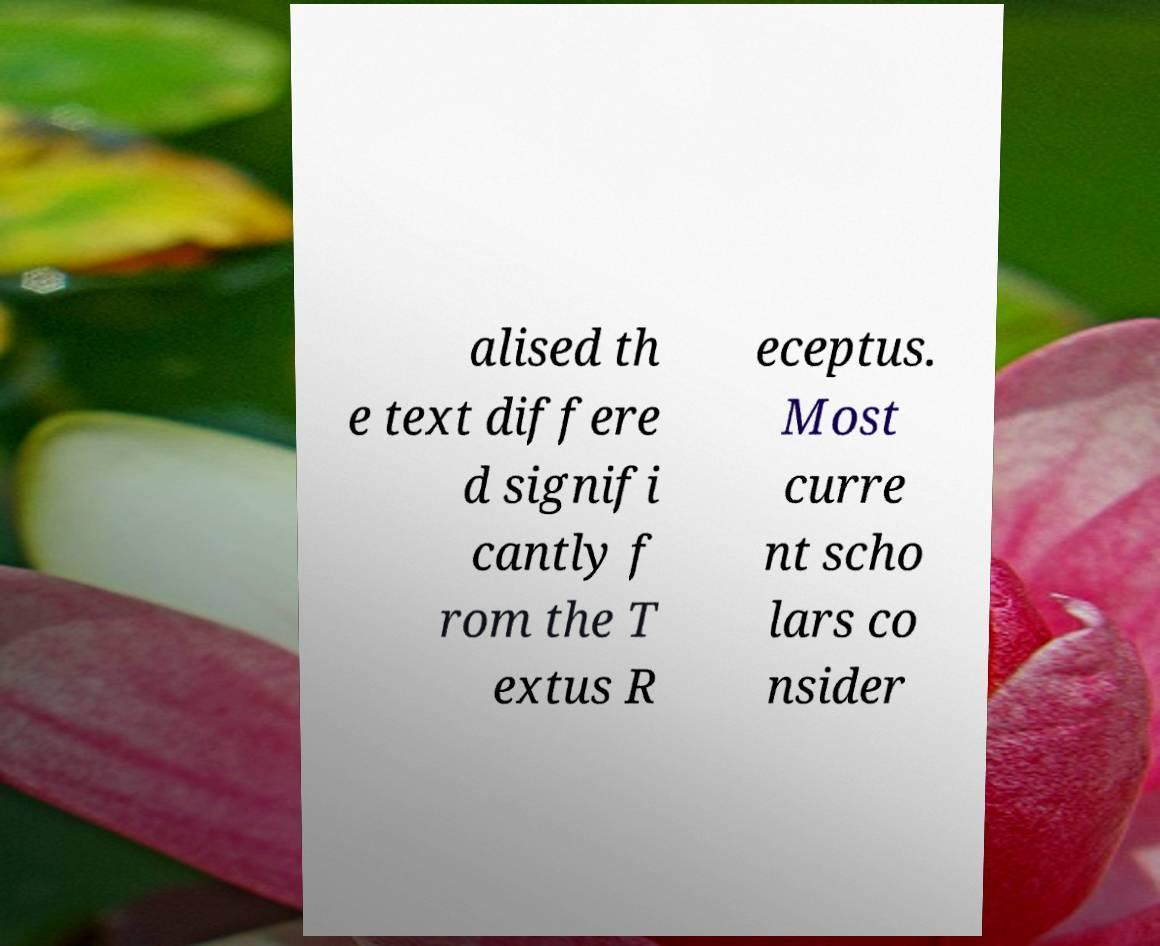Can you read and provide the text displayed in the image?This photo seems to have some interesting text. Can you extract and type it out for me? alised th e text differe d signifi cantly f rom the T extus R eceptus. Most curre nt scho lars co nsider 